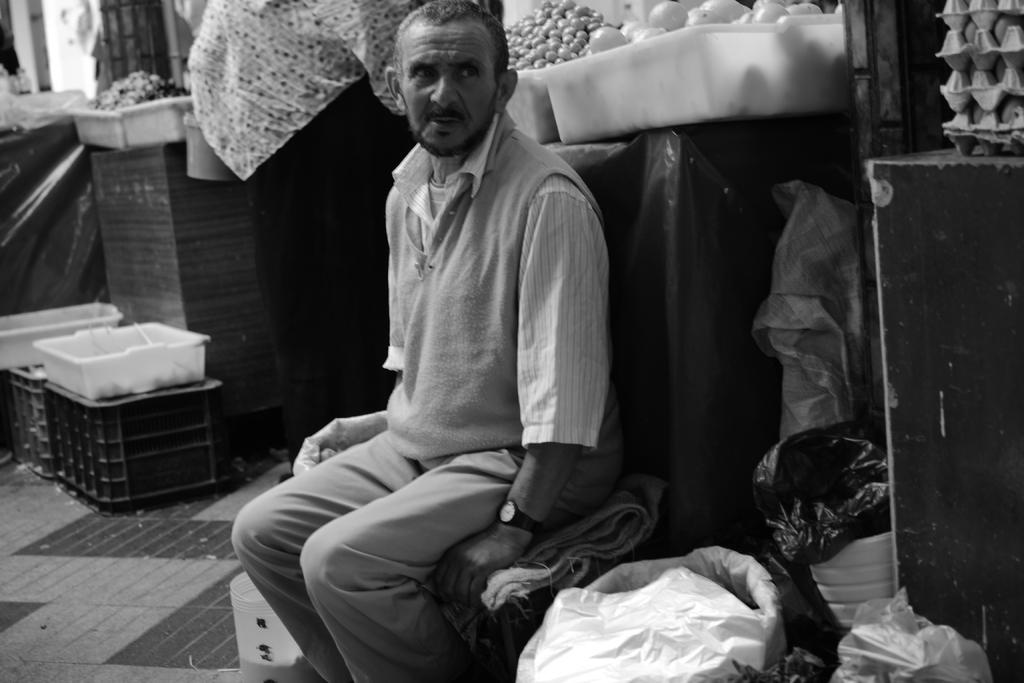What is the color scheme of the image? The image is black and white. What is the man in the image doing? The man is sitting on some tool in the image. What type of food items can be seen in the image? Onions and eggs are visible in the image. Can you describe any other items in the image? There are other items in the image, but their specific details are not mentioned in the facts. What type of place does the image appear to depict? The setting appears to be a store. What type of toothpaste is being used to decorate the plate in the image? There is no toothpaste or plate present in the image. What type of education is being offered in the image? The image does not depict any educational setting or activity. 